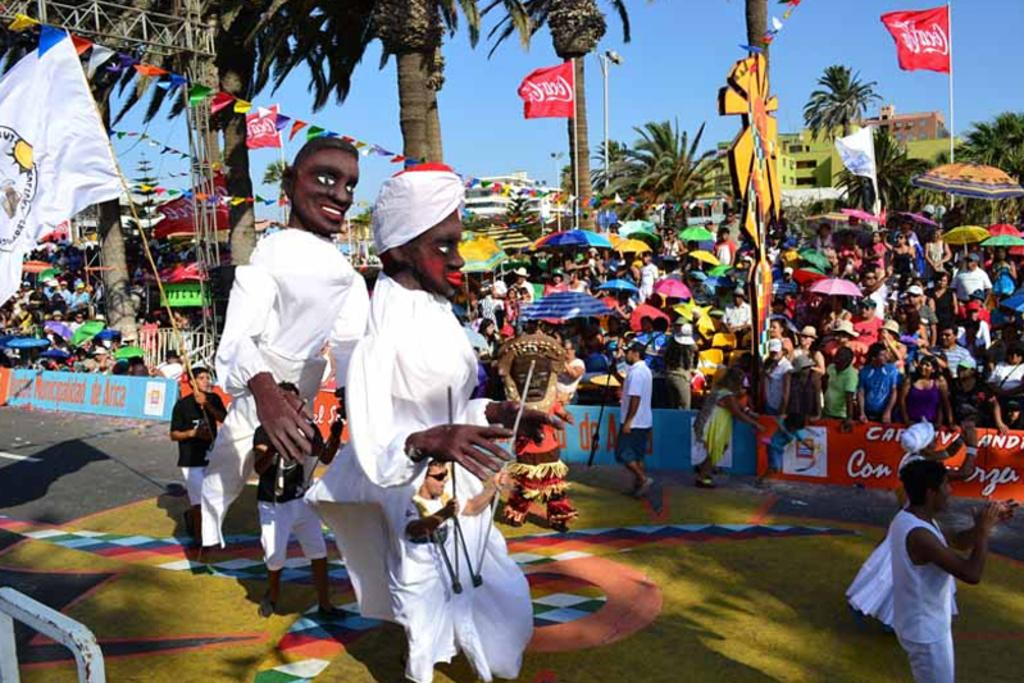<image>
Relay a brief, clear account of the picture shown. Coca Cola is the brand name shown on several waving flags. 